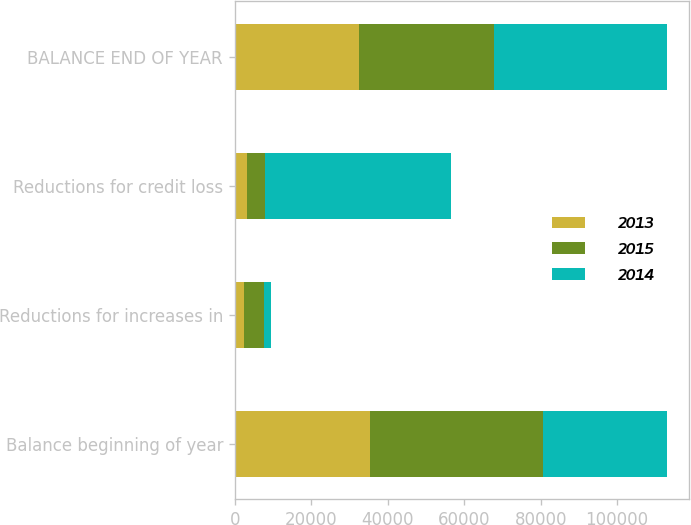<chart> <loc_0><loc_0><loc_500><loc_500><stacked_bar_chart><ecel><fcel>Balance beginning of year<fcel>Reductions for increases in<fcel>Reductions for credit loss<fcel>BALANCE END OF YEAR<nl><fcel>2013<fcel>35424<fcel>2398<fcel>3270<fcel>32377<nl><fcel>2015<fcel>45278<fcel>5248<fcel>4636<fcel>35424<nl><fcel>2014<fcel>32377<fcel>1851<fcel>48567<fcel>45278<nl></chart> 